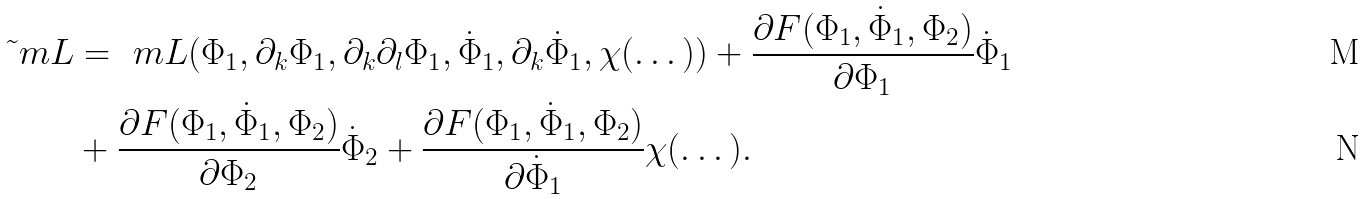<formula> <loc_0><loc_0><loc_500><loc_500>\tilde { \ } m L & = \ m L ( \Phi _ { 1 } , \partial _ { k } \Phi _ { 1 } , \partial _ { k } \partial _ { l } \Phi _ { 1 } , \dot { \Phi } _ { 1 } , \partial _ { k } \dot { \Phi } _ { 1 } , \chi ( \dots ) ) + \frac { \partial F ( \Phi _ { 1 } , \dot { \Phi } _ { 1 } , \Phi _ { 2 } ) } { \partial \Phi _ { 1 } } \dot { \Phi } _ { 1 } \\ & + \frac { \partial F ( \Phi _ { 1 } , \dot { \Phi } _ { 1 } , \Phi _ { 2 } ) } { \partial \Phi _ { 2 } } \dot { \Phi } _ { 2 } + \frac { \partial F ( \Phi _ { 1 } , \dot { \Phi } _ { 1 } , \Phi _ { 2 } ) } { \partial \dot { \Phi } _ { 1 } } \chi ( \dots ) .</formula> 